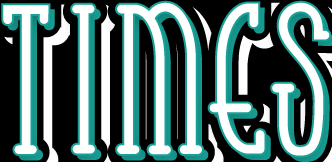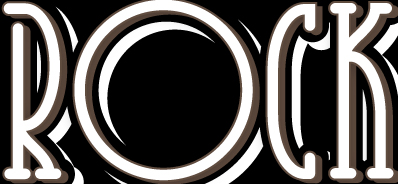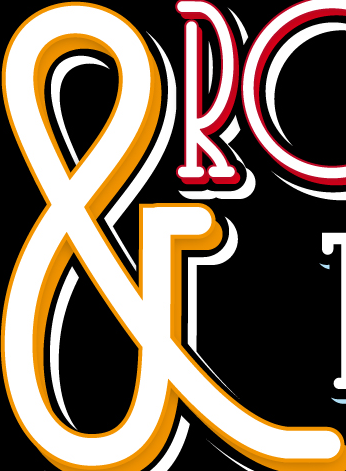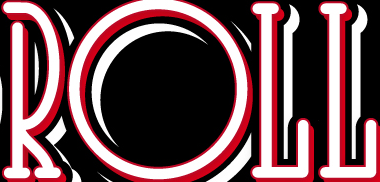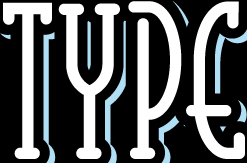What text is displayed in these images sequentially, separated by a semicolon? TIMES; ROCK; &; ROLL; TYPE 